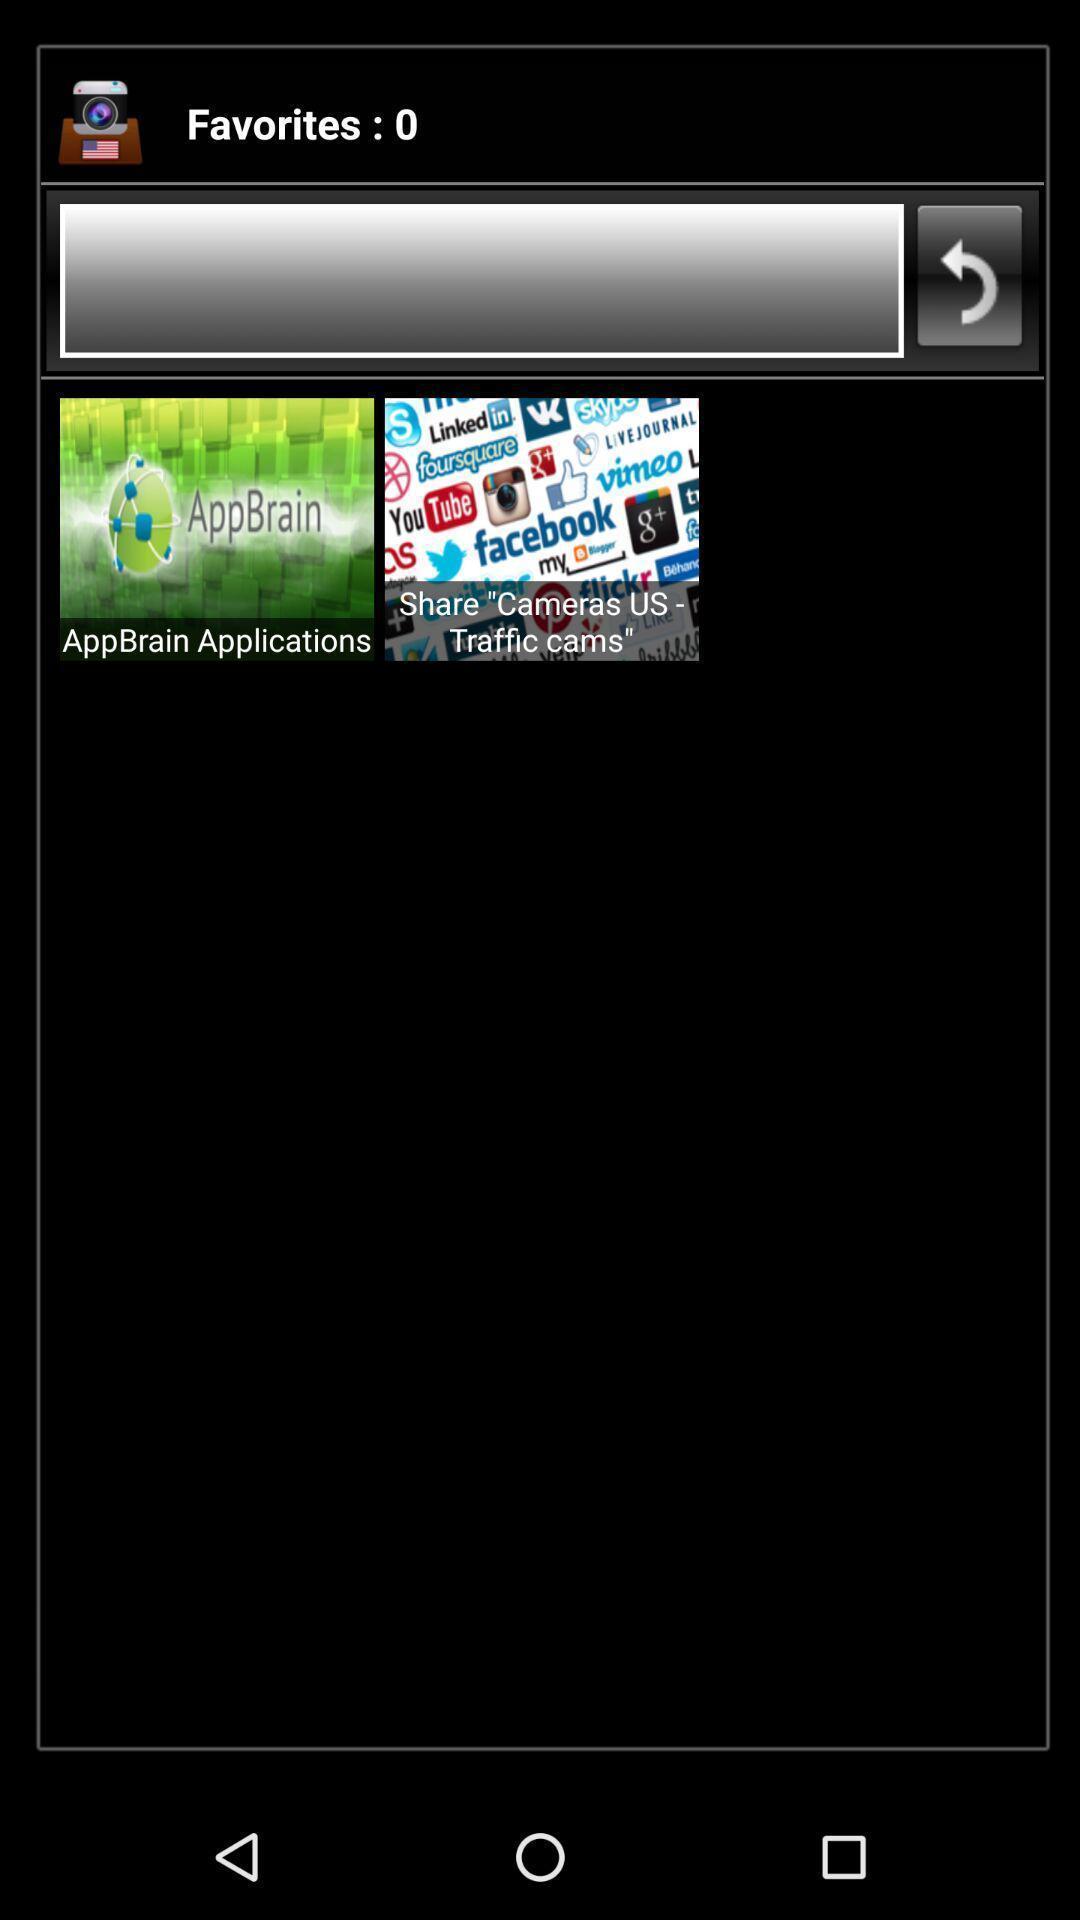Describe the key features of this screenshot. Screen showing traffic cams. 